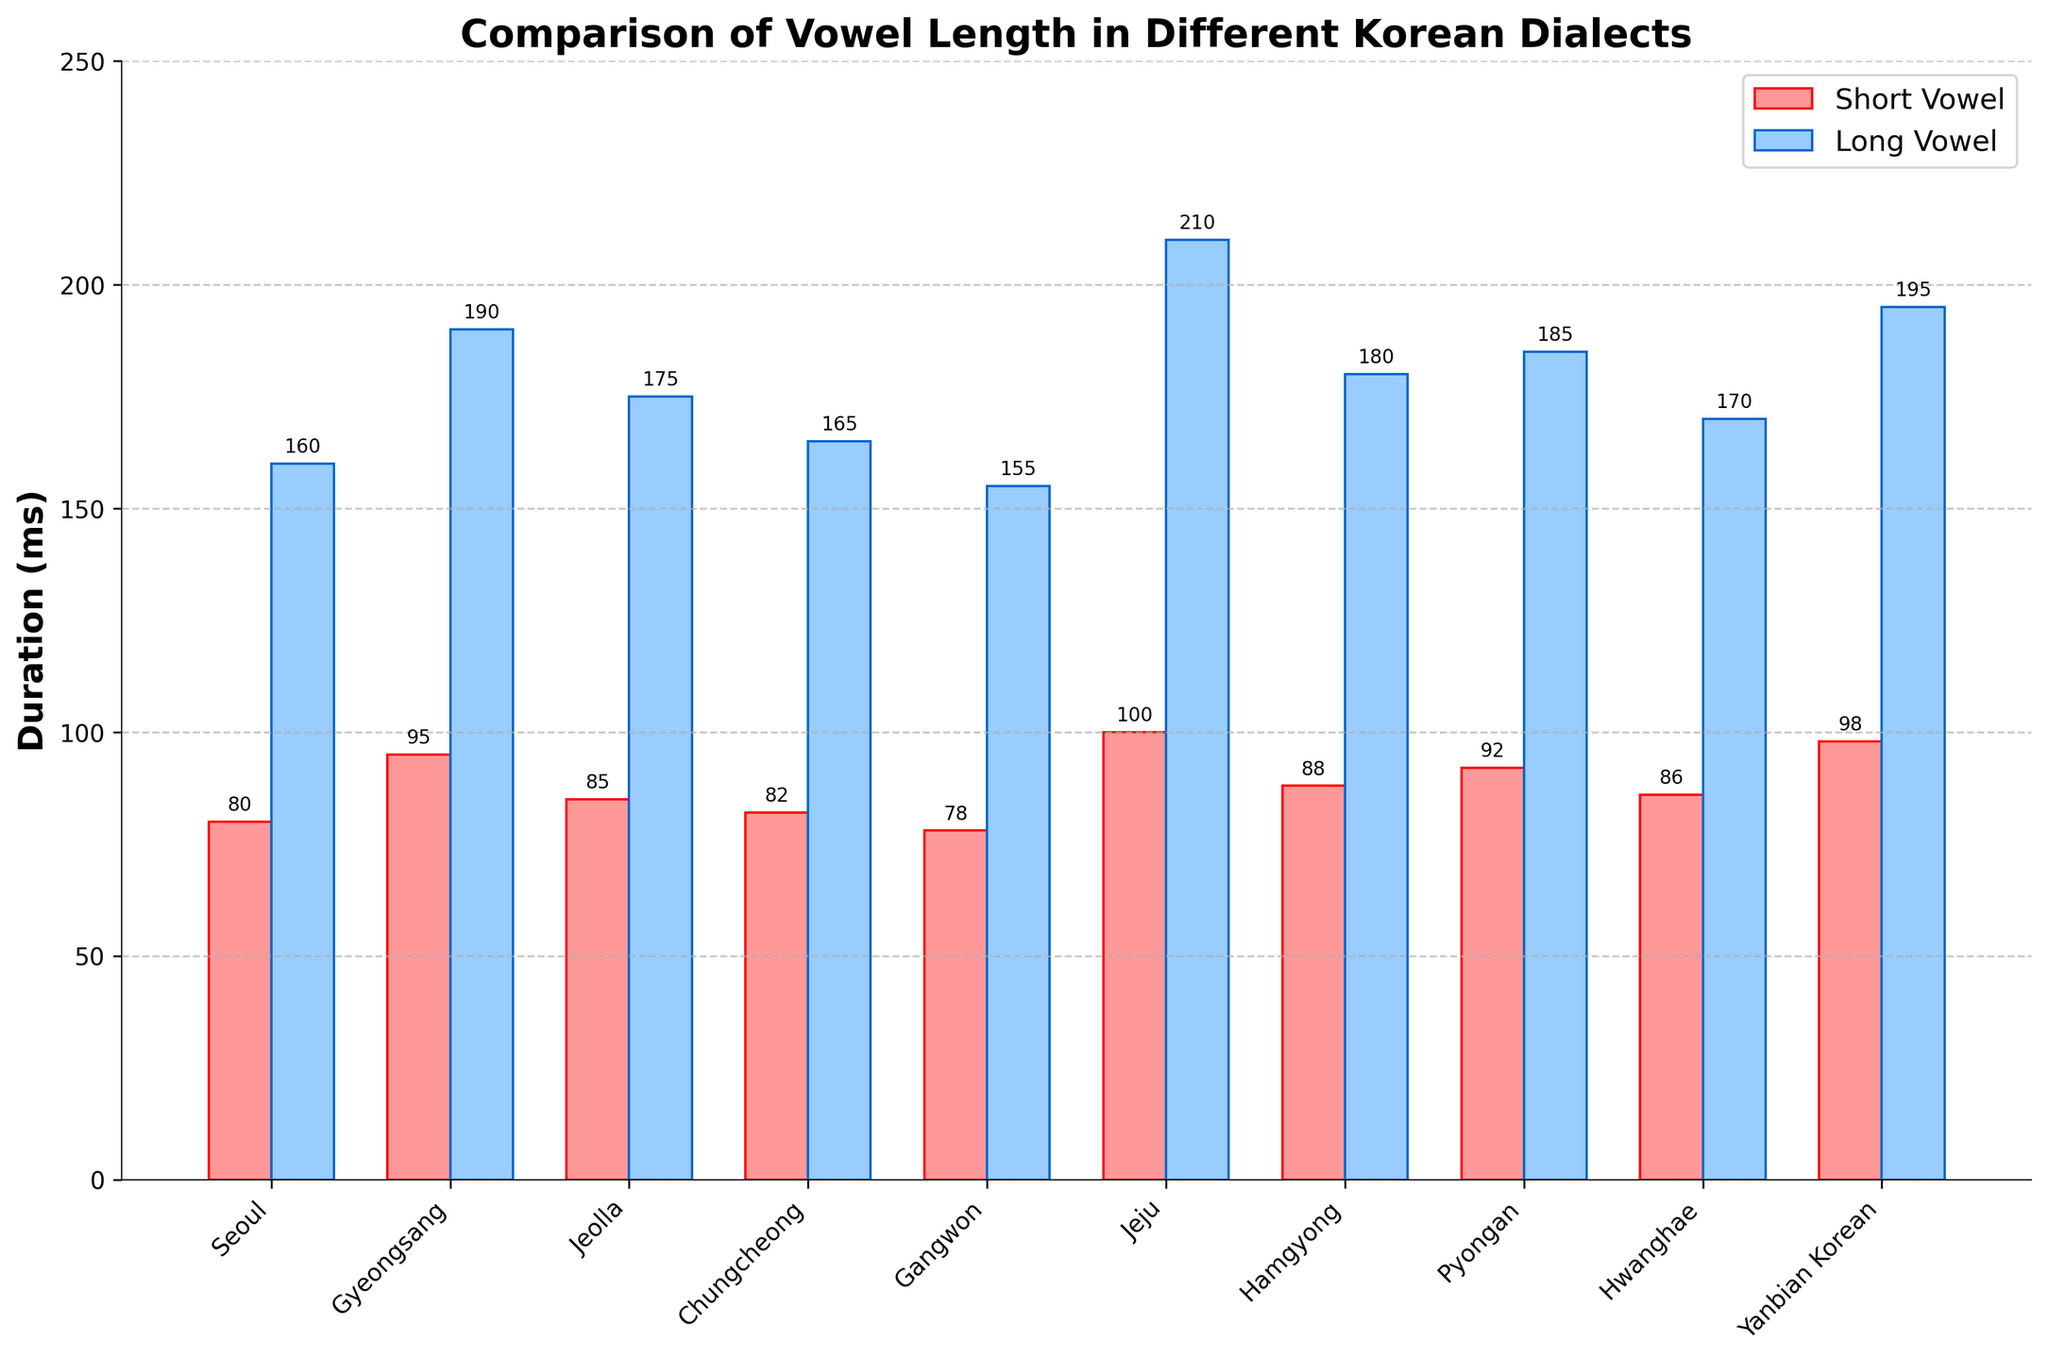Which dialect has the highest long vowel duration? Find the tallest blue bar in the figure, which represents the long vowel duration. The tallest blue bar is for Jeju.
Answer: Jeju Comparing Seoul and Gyeongsang dialects, which has a longer short vowel duration and by how much? Refer to the heights of the red bars for Seoul and Gyeongsang. Seoul has a duration of 80 ms, while Gyeongsang has 95 ms. The difference is 95 - 80 = 15 ms.
Answer: Gyeongsang, 15 ms What is the average duration of short vowels across all dialects? Sum the short vowel durations for all dialects (80 + 95 + 85 + 82 + 78 + 100 + 88 + 92 + 86 + 98) = 884 ms, then divide by the number of dialects (10). The average is 884 / 10 = 88.4 ms.
Answer: 88.4 ms Which dialect shows the smallest difference between short and long vowel durations? Calculate the difference for each dialect and compare: 
Seoul: 160 - 80 = 80,
Gyeongsang: 190 - 95 = 95,
Jeolla: 175 - 85 = 90,
Chungcheong: 165 - 82 = 83,
Gangwon: 155 - 78 = 77,
Jeju: 210 - 100 = 110,
Hamgyong: 180 - 88 = 92,
Pyongan: 185 - 92 = 93,
Hwanghae: 170 - 86 = 84,
Yanbian Korean: 195 - 98 = 97. 
Gangwon has the smallest difference of 77 ms.
Answer: Gangwon What is the total duration of long vowels for Chungcheong and Jeolla dialects combined? Sum the long vowel durations for Chungcheong and Jeolla. Chungcheong has 165 ms and Jeolla has 175 ms. The total is 165 + 175 = 340 ms.
Answer: 340 ms How many dialects have a short vowel duration less than 85 ms? Compare the short vowel durations and count those less than 85 ms: Seoul (80), Chungcheong (82), Gangwon (78). There are 3 dialects.
Answer: 3 Which dialect has a long vowel duration of 185 ms? Check the heights of the bars in the blue column to find the one that corresponds to 185 ms. This matches Pyongan.
Answer: Pyongan Are there any dialects where the short vowel duration is greater than or equal to 90 ms? Check the red bars to see which short vowel durations are >= 90 ms: Gyeongsang and Yanbian Korean (both 95 and 98).
Answer: Gyeongsang, Yanbian Korean What is the difference between the highest and lowest short vowel duration values? Identify the highest (Jeju, 100 ms) and the lowest (Gangwon, 78 ms) short vowel durations, then subtract the lowest from the highest: 100 - 78 = 22 ms.
Answer: 22 ms 